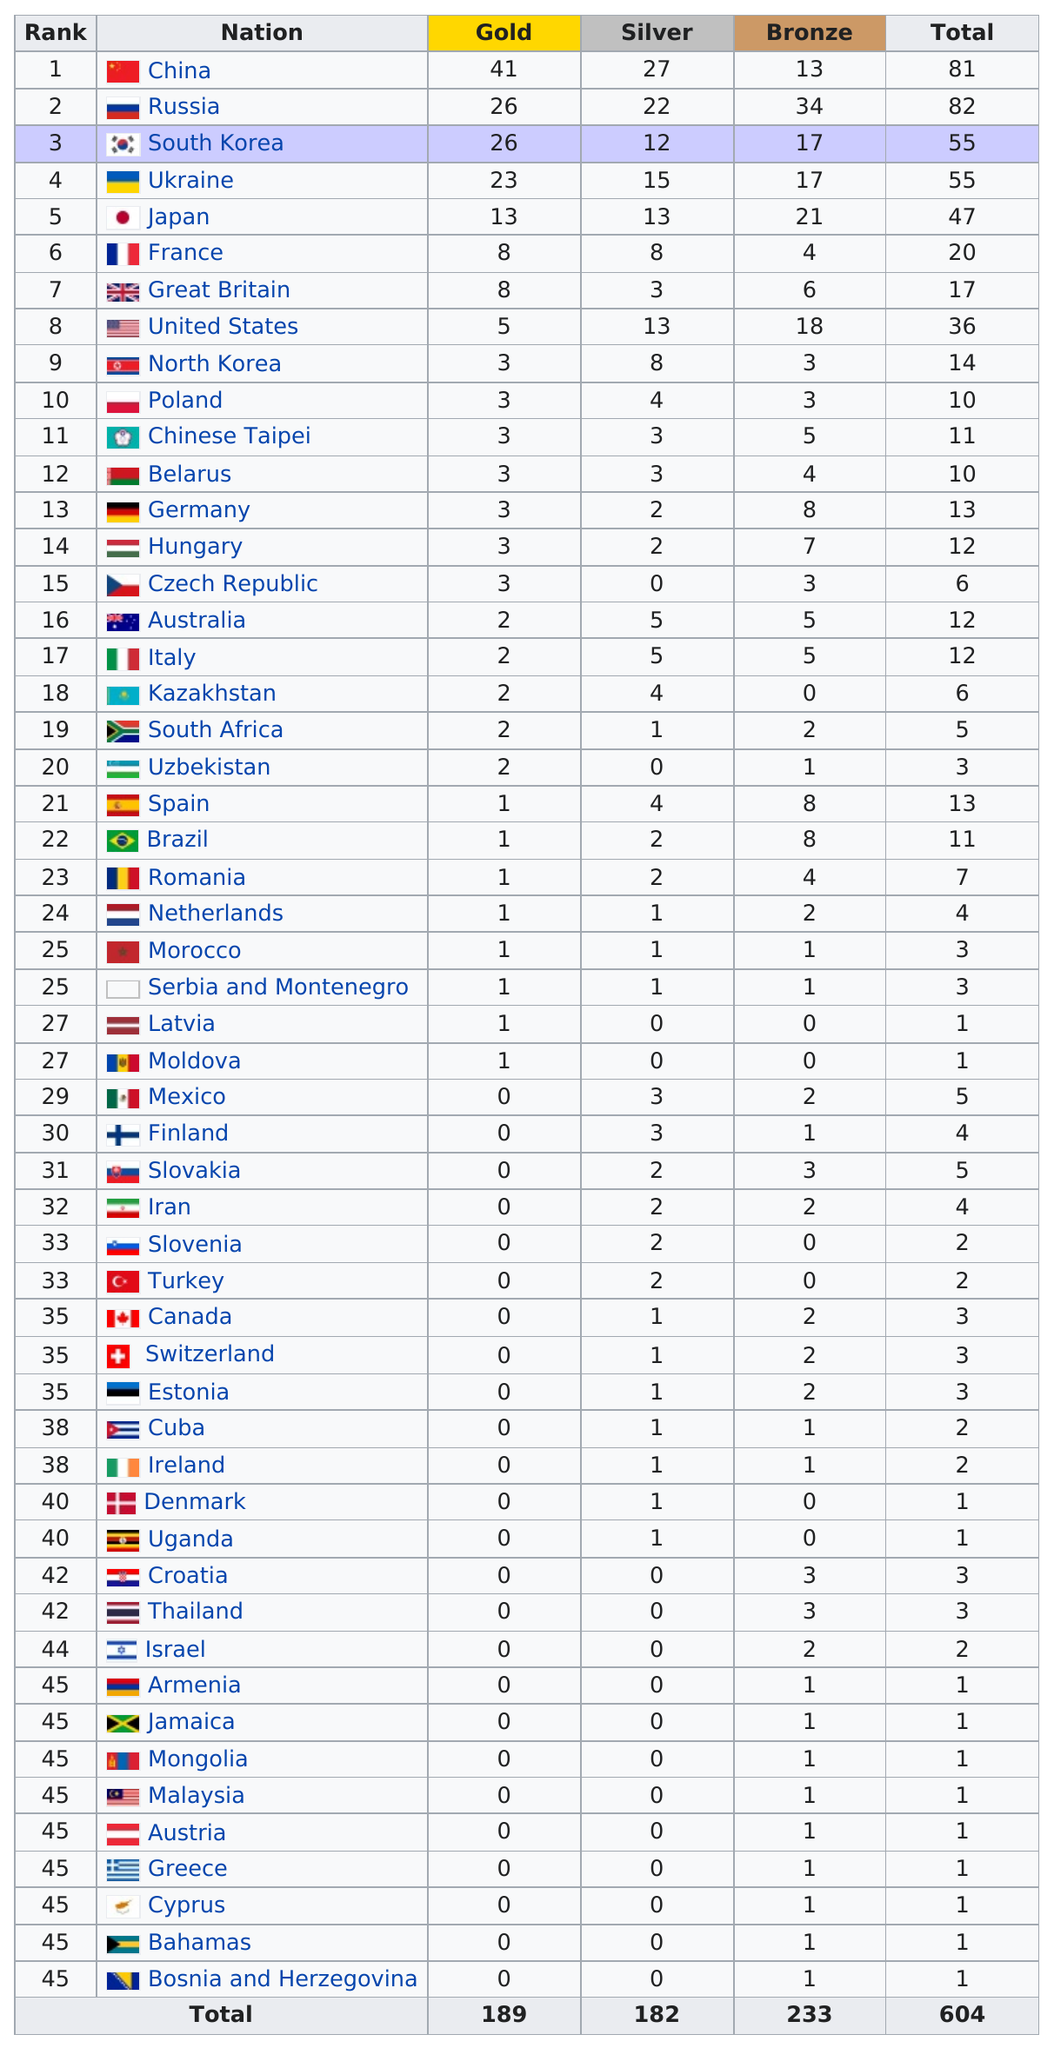Draw attention to some important aspects in this diagram. The 2003 Summer Universiade was held in Daegu, South Korea, and China earned the highest total number of medals among all participating countries. The total number of medals earned by the top 15 ranked athletes was 62. During the 2003 Summer Universiade, Russia, Japan, and the United States each had at least 18 bronze medals. The top three nations earned a combined total of 93 gold medals. The top medal winner was China, as they were the country with the most number of medals. 